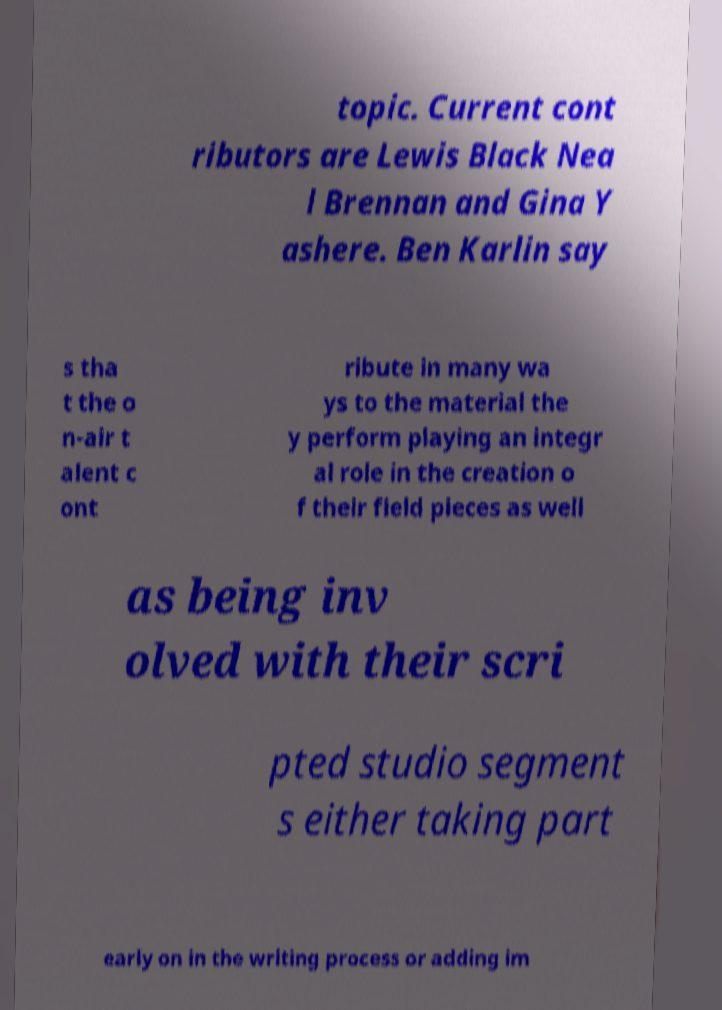Could you extract and type out the text from this image? topic. Current cont ributors are Lewis Black Nea l Brennan and Gina Y ashere. Ben Karlin say s tha t the o n-air t alent c ont ribute in many wa ys to the material the y perform playing an integr al role in the creation o f their field pieces as well as being inv olved with their scri pted studio segment s either taking part early on in the writing process or adding im 